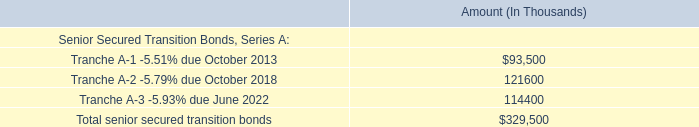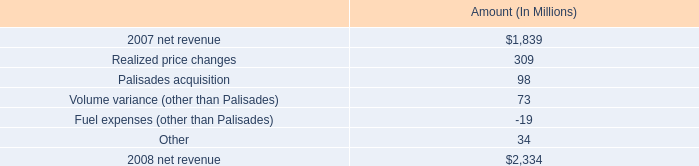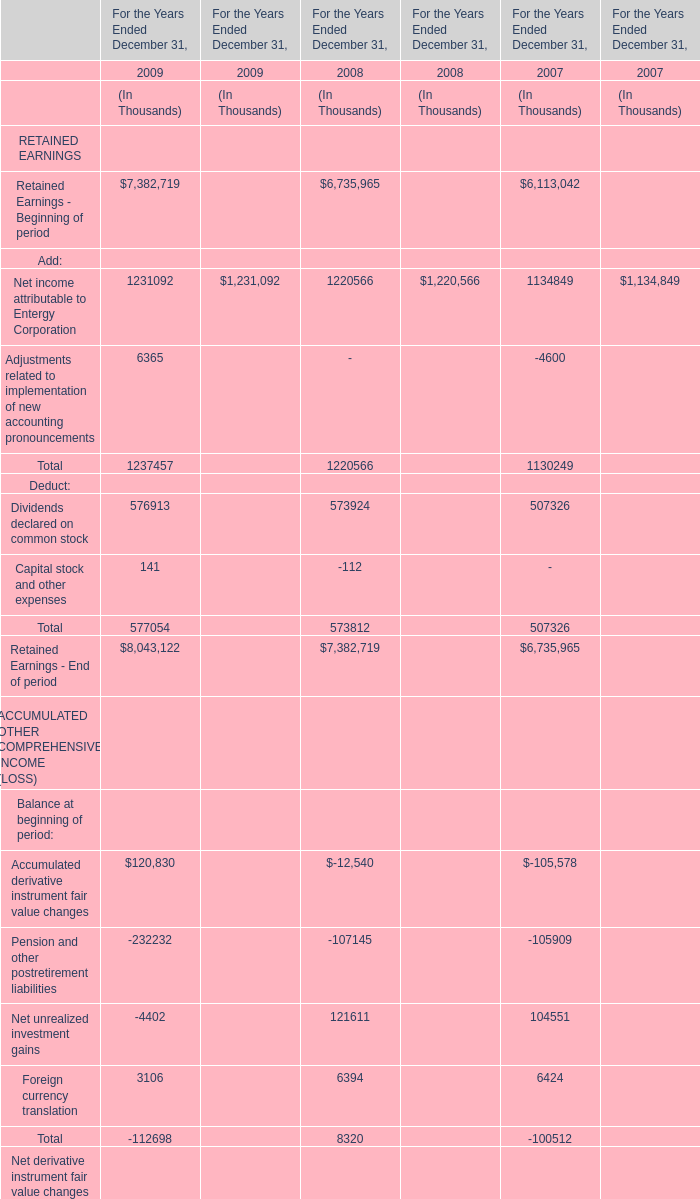What was the total amount of Retained Earnings - Beginning of period in the range of 6000000 and 8000000 For the Years Ended December 31 ? (in thousand) 
Computations: ((7382719 + 6735965) + 6113042)
Answer: 20231726.0. 